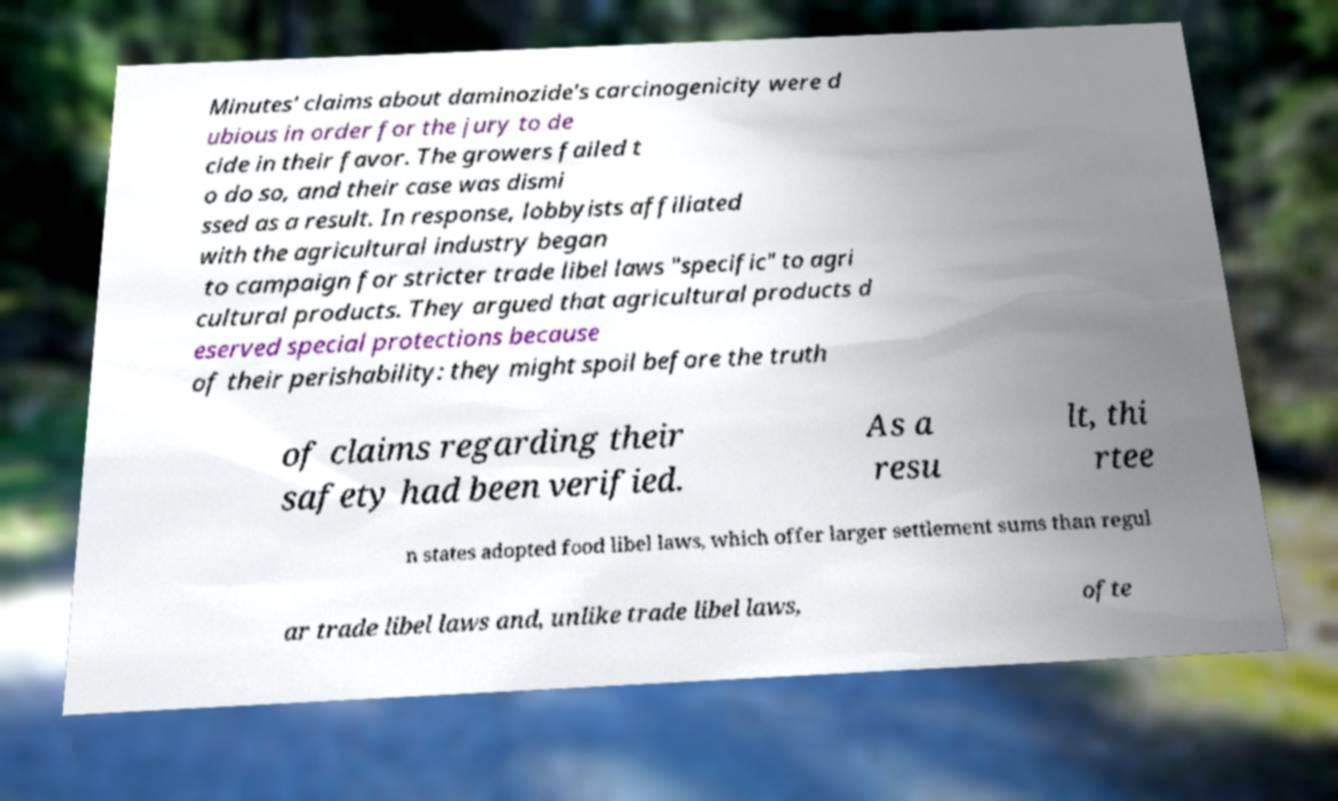Can you read and provide the text displayed in the image?This photo seems to have some interesting text. Can you extract and type it out for me? Minutes' claims about daminozide's carcinogenicity were d ubious in order for the jury to de cide in their favor. The growers failed t o do so, and their case was dismi ssed as a result. In response, lobbyists affiliated with the agricultural industry began to campaign for stricter trade libel laws "specific" to agri cultural products. They argued that agricultural products d eserved special protections because of their perishability: they might spoil before the truth of claims regarding their safety had been verified. As a resu lt, thi rtee n states adopted food libel laws, which offer larger settlement sums than regul ar trade libel laws and, unlike trade libel laws, ofte 